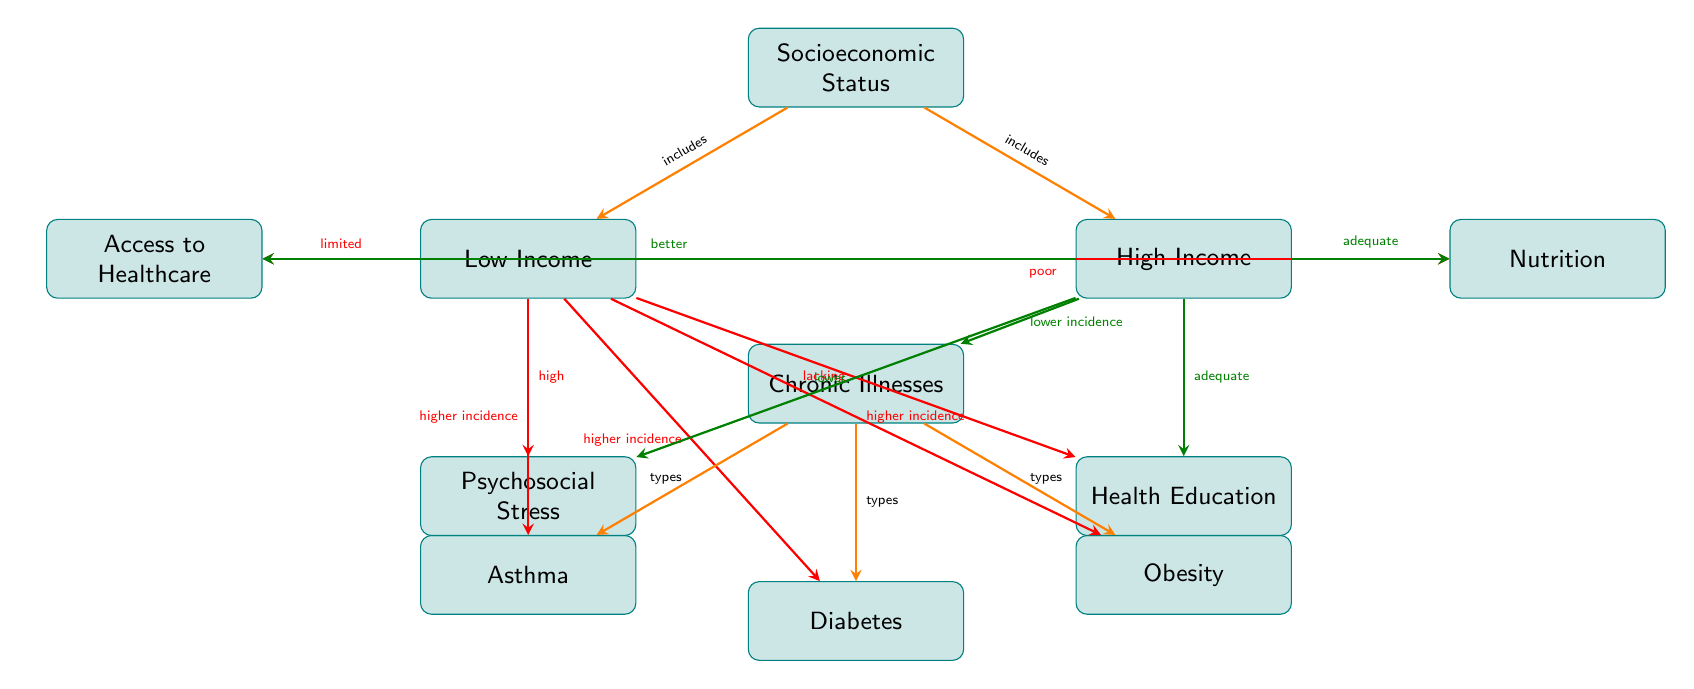What are the types of chronic illnesses represented in the diagram? The diagram lists three types of chronic illnesses: Asthma, Diabetes, and Obesity. This can be identified directly from the nodes branching out from the "Chronic Illnesses" node.
Answer: Asthma, Diabetes, Obesity Which socioeconomic group has a higher incidence of chronic illnesses? The "Low Income" node is directly indicated by an arrow showing "higher incidence" towards all three types of chronic illnesses. This shows that children from this socioeconomic group are more prone to these illnesses.
Answer: Low Income How many nodes represent socioeconomic status in the diagram? There are two nodes representing socioeconomic status: "Low Income" and "High Income." These can be counted directly in the diagram under the "Socioeconomic Status" node.
Answer: 2 What effect does high socioeconomic status have on access to healthcare? The "High Income" node has an arrow labeled "better" pointing towards the "Access to Healthcare" node, indicating that higher socioeconomic status leads to better access.
Answer: Better Which factor associated with low socioeconomic status leads to obesity? The arrow from the "Low Income" node to the "Obesity" node is labeled "higher incidence," indicating this association. It is understood that children in low-income situations have a higher incidence of obesity due to multiple contributing factors.
Answer: Higher incidence What type of chronic illness is linked to psychosocial stress? The "Psychosocial Stress" node, which is connected to the "Low Income" node, has arrows indicating negative implications, and the diagram shows that chronic illnesses such as "Asthma," "Diabetes," and "Obesity" all stem from low socioeconomic status. The reasoning leads us to associate these illnesses with stress indirectly.
Answer: Asthma, Diabetes, Obesity How does nutrition influence chronic illnesses in children with low income? The diagram indicates that low-income status is linked to "poor" nutrition. This poor nutritional status can logically contribute to the higher incidences of chronic illnesses like obesity, which allows us to infer the influence of nutrition on health outcomes in this group.
Answer: Poor What type of education is linked to high socioeconomic status? The "High Income" node directs towards the "Education" node, which is labeled "adequate," implying that individuals in high socioeconomic groups typically receive better education about health.
Answer: Adequate 